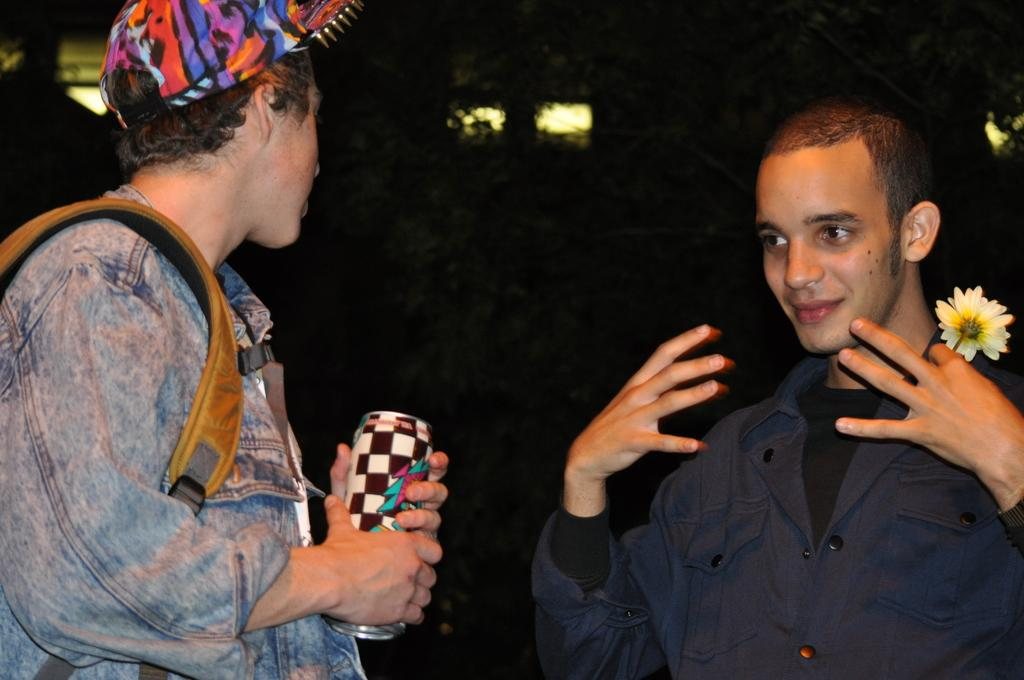How many people are in the image? There are two people standing in the image. What is the man on the right holding? The man on the right is holding a flower. What is the other man holding? The other man is holding a tin. What can be seen in the background of the image? There are lights visible in the background of the image. What type of silk is draped over the cloud in the image? There is no cloud or silk present in the image. 